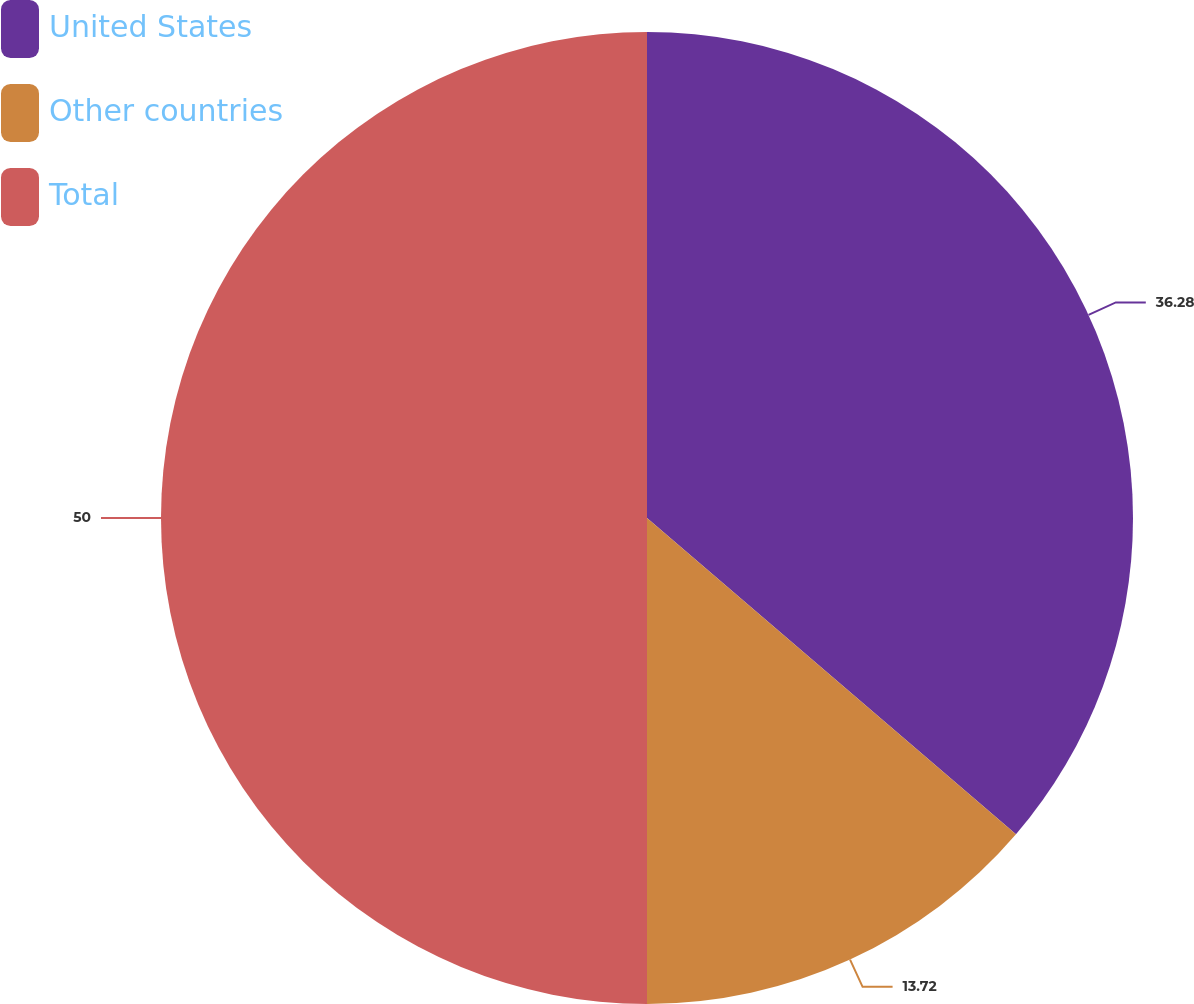Convert chart to OTSL. <chart><loc_0><loc_0><loc_500><loc_500><pie_chart><fcel>United States<fcel>Other countries<fcel>Total<nl><fcel>36.28%<fcel>13.72%<fcel>50.0%<nl></chart> 